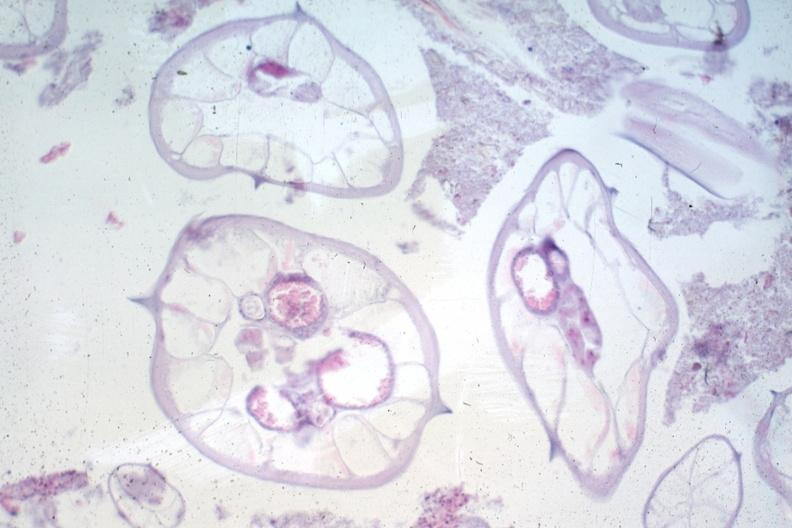where is this from?
Answer the question using a single word or phrase. Gastrointestinal system 